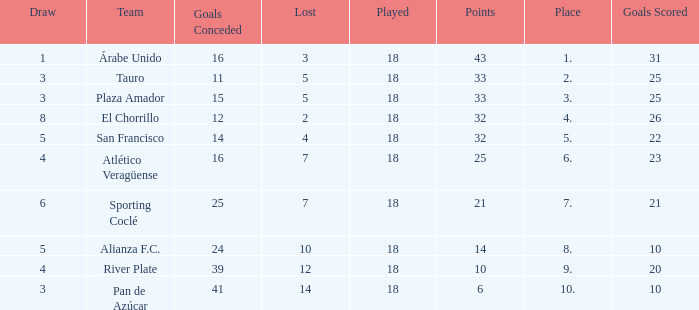How many points did the team have that conceded 41 goals and finish in a place larger than 10? 0.0. 